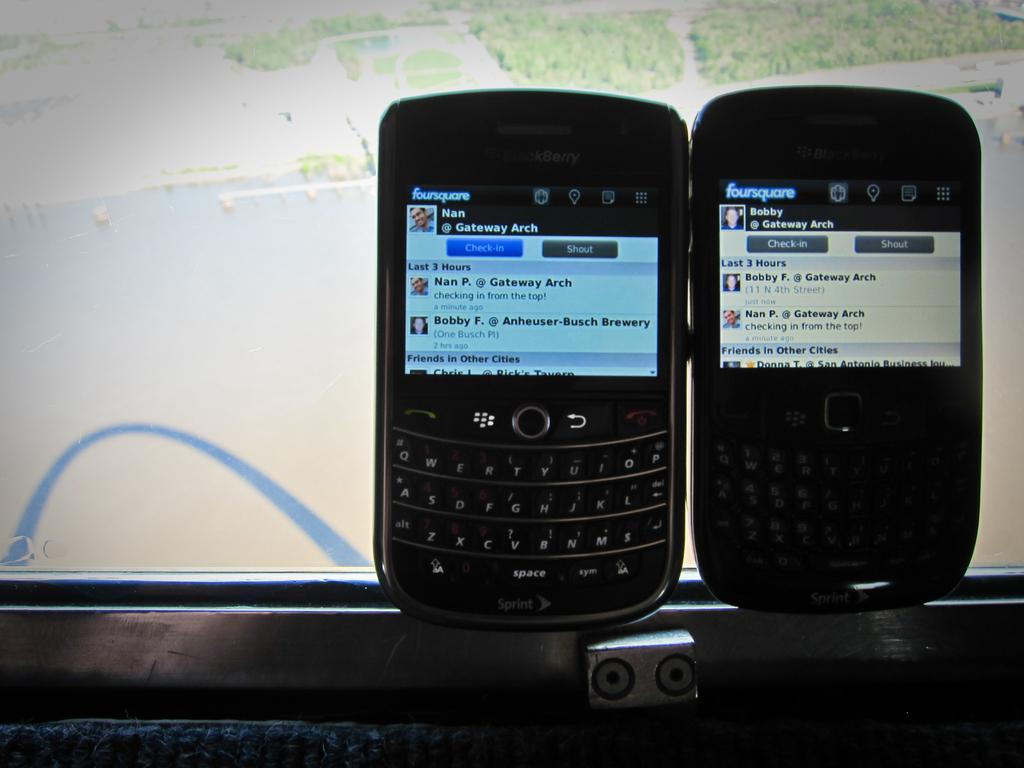<image>
Offer a succinct explanation of the picture presented. In front of the monitor a cell phone displace two buttons , one is Check-in the other is Shout. 